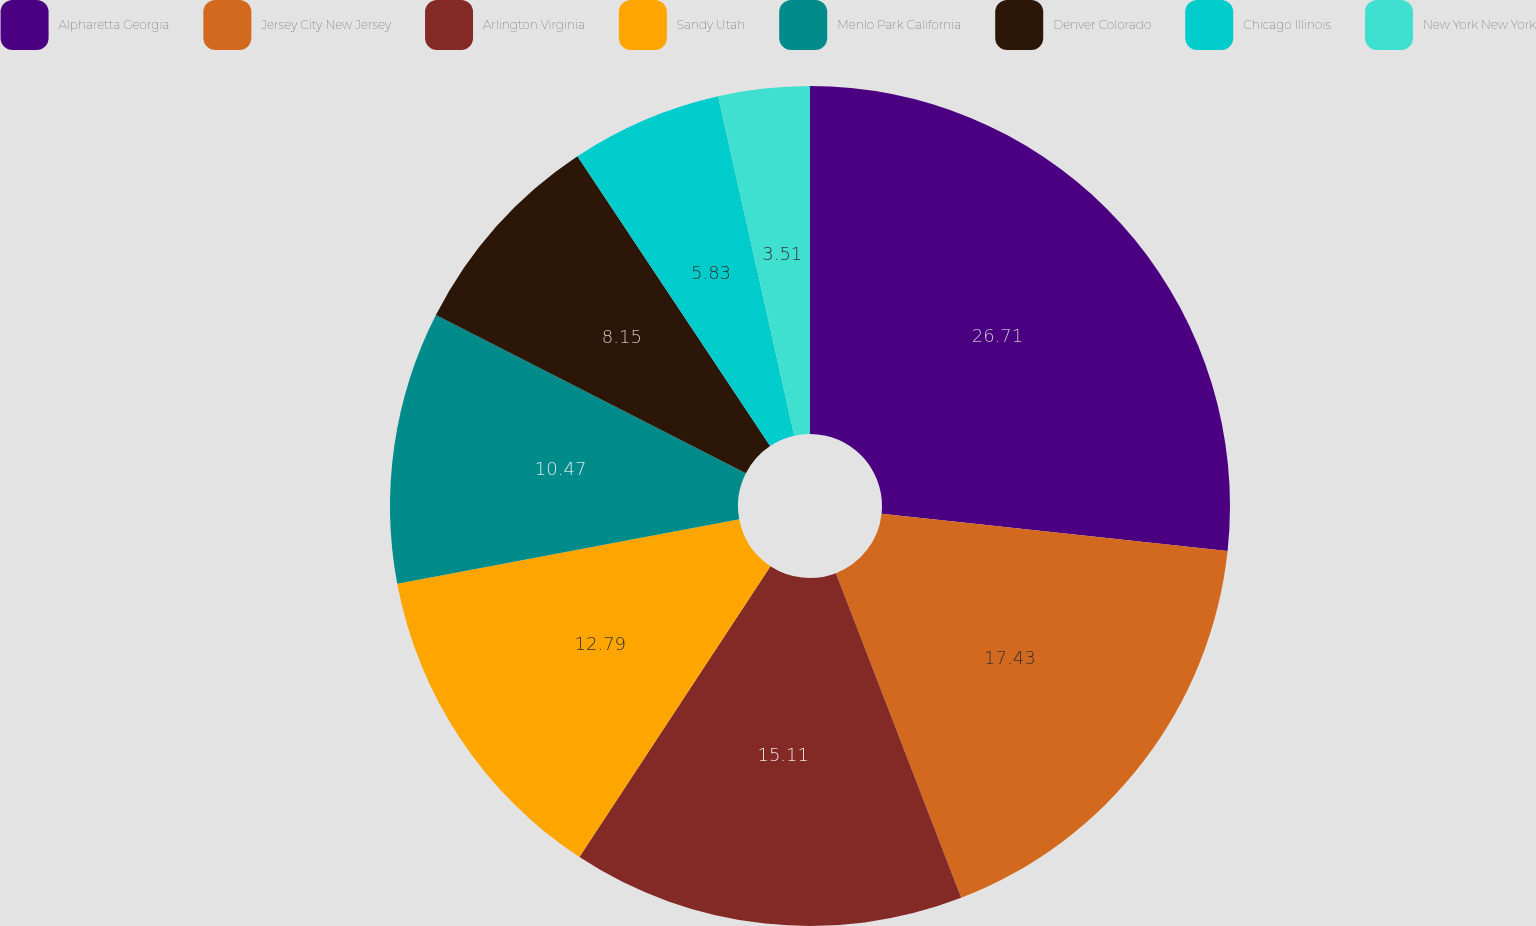<chart> <loc_0><loc_0><loc_500><loc_500><pie_chart><fcel>Alpharetta Georgia<fcel>Jersey City New Jersey<fcel>Arlington Virginia<fcel>Sandy Utah<fcel>Menlo Park California<fcel>Denver Colorado<fcel>Chicago Illinois<fcel>New York New York<nl><fcel>26.71%<fcel>17.43%<fcel>15.11%<fcel>12.79%<fcel>10.47%<fcel>8.15%<fcel>5.83%<fcel>3.51%<nl></chart> 